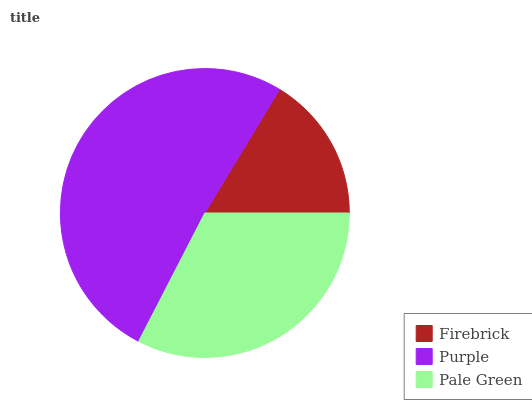Is Firebrick the minimum?
Answer yes or no. Yes. Is Purple the maximum?
Answer yes or no. Yes. Is Pale Green the minimum?
Answer yes or no. No. Is Pale Green the maximum?
Answer yes or no. No. Is Purple greater than Pale Green?
Answer yes or no. Yes. Is Pale Green less than Purple?
Answer yes or no. Yes. Is Pale Green greater than Purple?
Answer yes or no. No. Is Purple less than Pale Green?
Answer yes or no. No. Is Pale Green the high median?
Answer yes or no. Yes. Is Pale Green the low median?
Answer yes or no. Yes. Is Purple the high median?
Answer yes or no. No. Is Purple the low median?
Answer yes or no. No. 